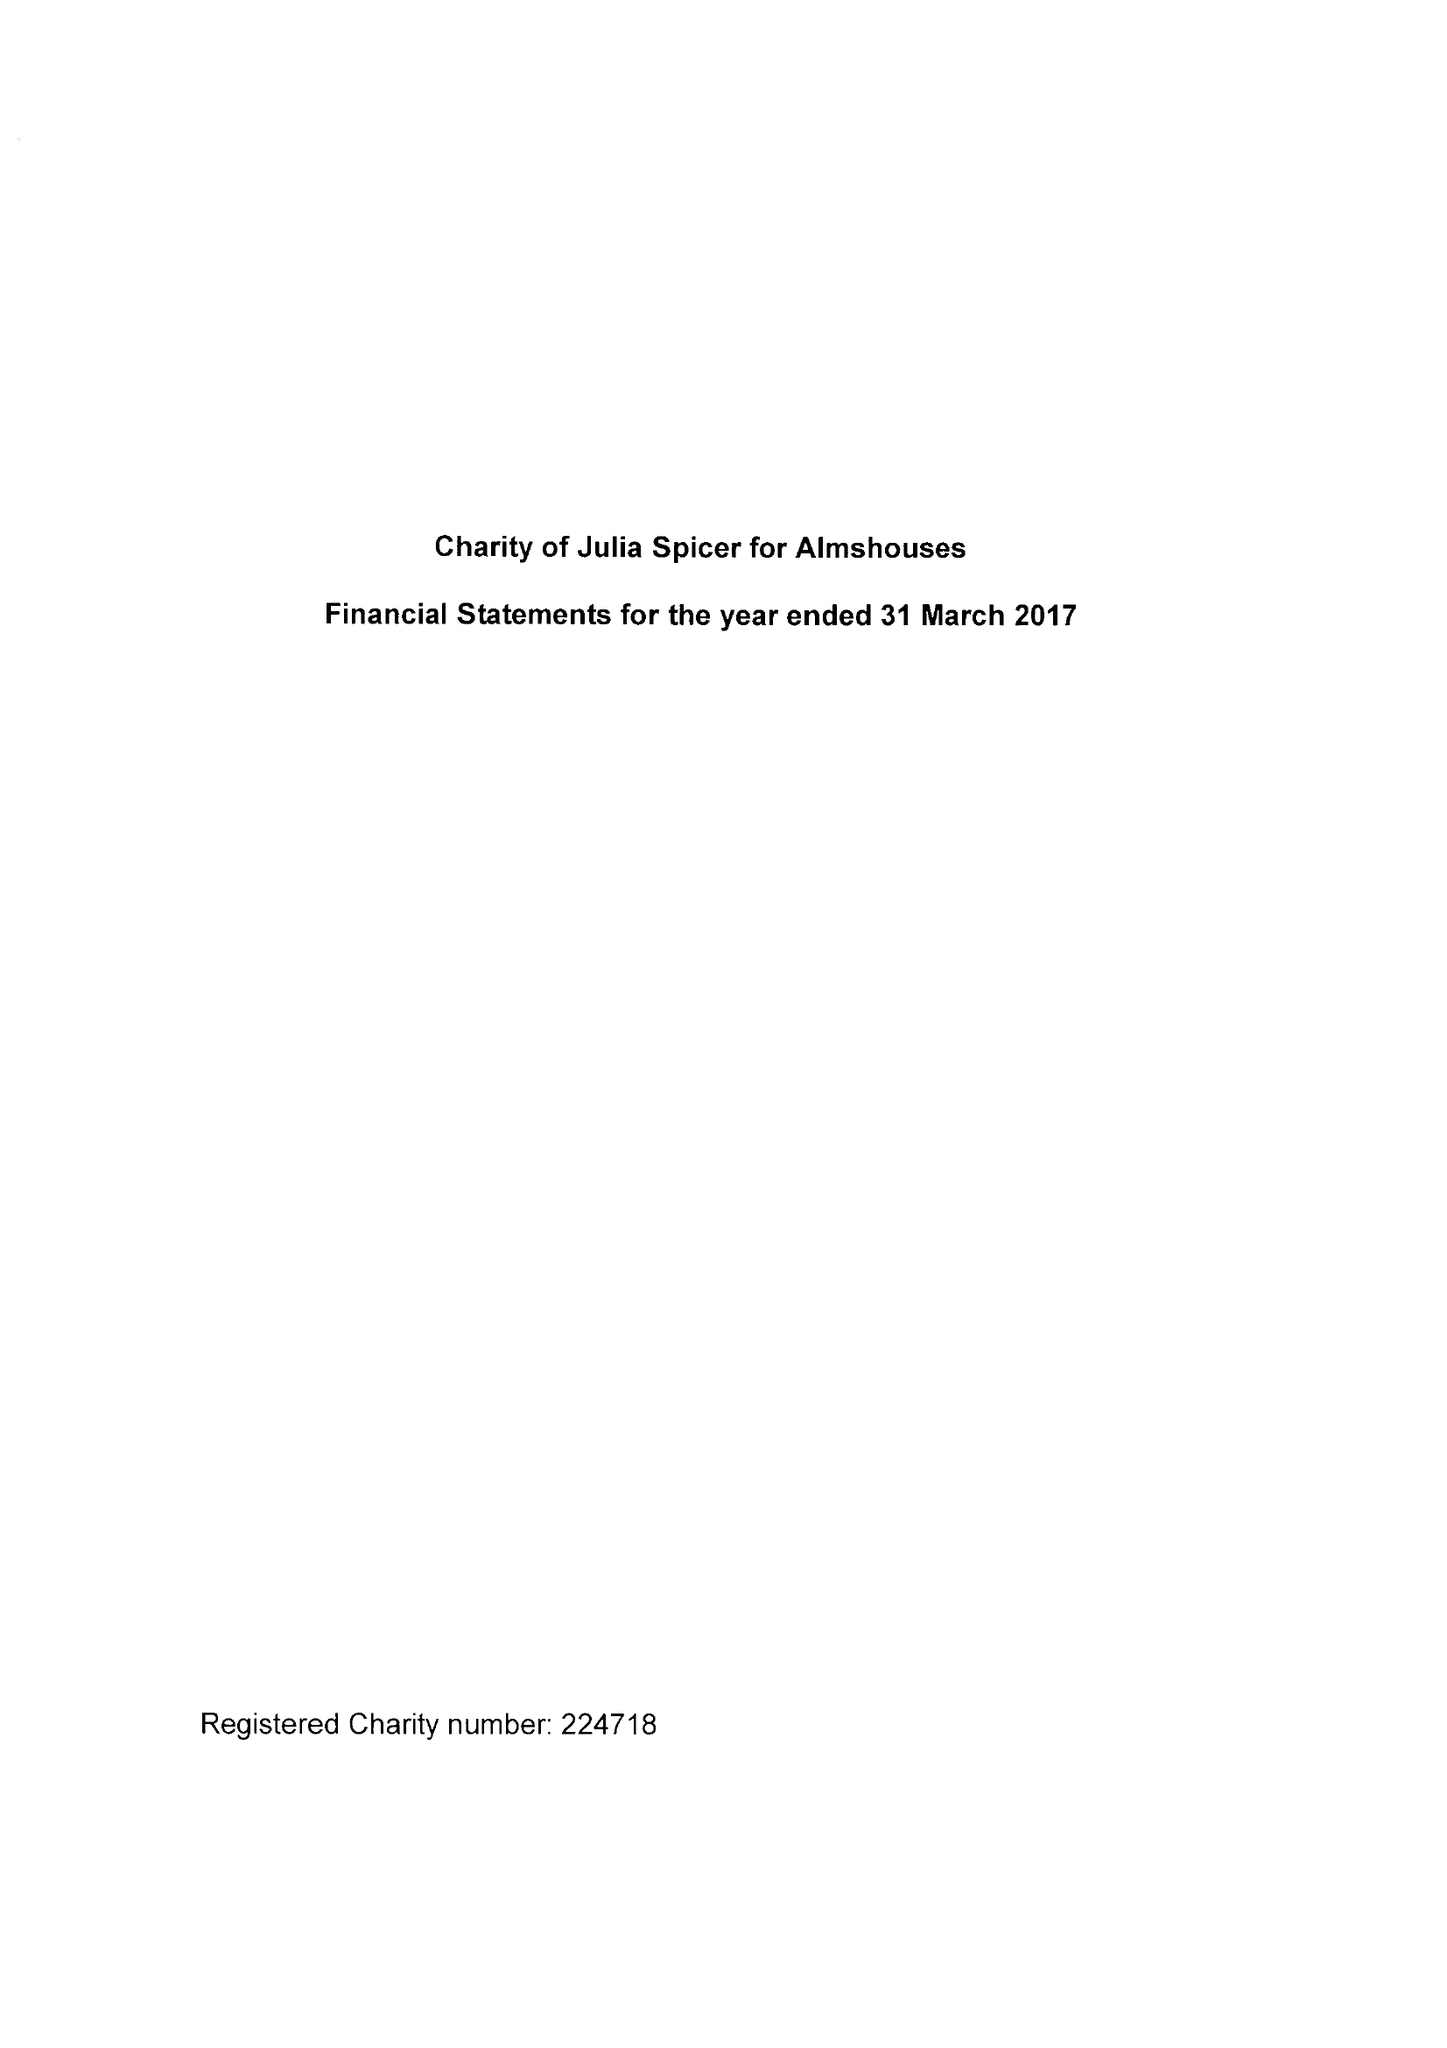What is the value for the report_date?
Answer the question using a single word or phrase. 2017-03-31 